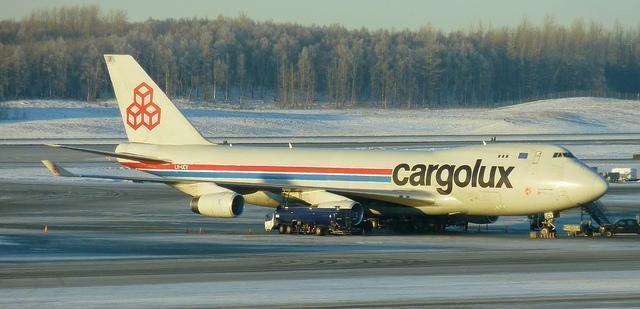How many people are wearing hats?
Give a very brief answer. 0. 